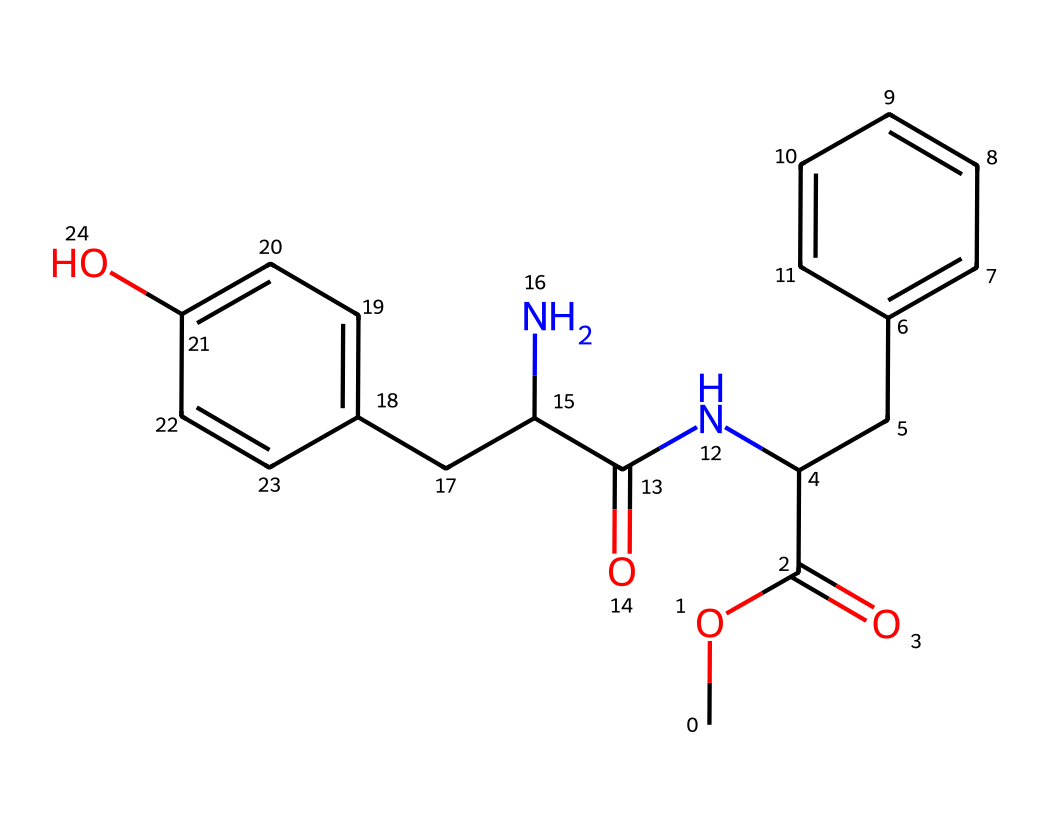How many carbon atoms are in aspartame? By examining the SMILES representation, we identify each "C" which denotes a carbon atom. The number of carbon atoms can also be counted directly from the structure drawn from the SMILES. In this case, we find that there are 15 carbon atoms present.
Answer: 15 What functional groups are present in aspartame? Looking at the SMILES, we can identify several functional groups: the ester group (indicated by "C(=O)" adjacent to "O"), amine group (indicated by "N"), and phenolic hydroxyl group (indicated by "C(C=C)O"). These highlight the key functional groups involved in the structure.
Answer: ester, amine, phenolic What is the molecular formula of aspartame? The molecular formula can be deduced by counting the atoms represented in the SMILES: there are 15 carbon (C), 18 hydrogen (H), 3 nitrogen (N), and 4 oxygen (O) atoms, which combine to give us the formula C15H18N2O4.
Answer: C15H18N2O4 How many rings are present in aspartame? By analyzing the SMILES structure, we identify the presence of two aromatic rings, which are evident from the "C=C" notations inside the structure. Each "C=C" indicates part of a ring, and we can note that these contribute to the overall structure of the compound.
Answer: 2 What is the significance of the nitrogen atom in aspartame? The nitrogen atom in the structure contributes to the amine functional group that is essential for the sweetness of the compound. Aspartame contains an amine which plays a key role in its taste characteristics.
Answer: sweetness What kind of sweetener is aspartame classified as? Aspartame is classified as a non-nutritive or artificial sweetener because it provides sweetness without calories. The structure reveals characteristics typical of sweetening agents, making it an example of such a compound.
Answer: artificial sweetener What is the primary source of the controversy surrounding aspartame? The controversy primarily arises from the health concerns associated with its consumption. Some studies have raised questions about safety, which can be inferred from discussions around chemicals with nitrogen or complex structures.
Answer: health concerns 